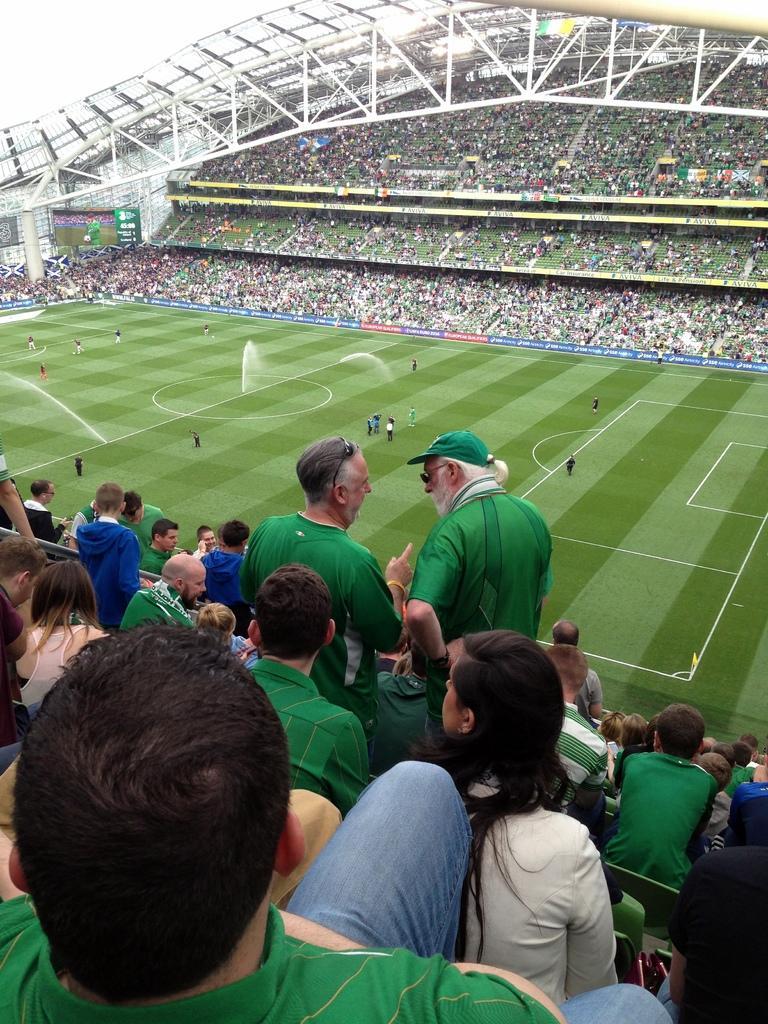Describe this image in one or two sentences. In this image there are a few players on the ground, on the either side of the ground there are spectators watching the game sitting in the stands. 